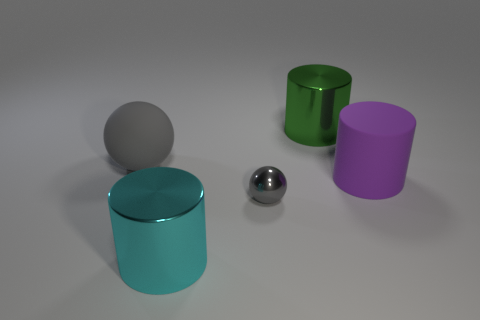What size is the object that is the same color as the small ball?
Your answer should be compact. Large. Is the large gray object the same shape as the purple thing?
Your response must be concise. No. What size is the other metal object that is the same shape as the large cyan shiny thing?
Keep it short and to the point. Large. The rubber thing to the left of the large cylinder that is behind the big gray rubber ball is what shape?
Ensure brevity in your answer.  Sphere. The purple rubber thing has what size?
Ensure brevity in your answer.  Large. What is the shape of the purple object?
Your response must be concise. Cylinder. There is a large gray object; is its shape the same as the gray object that is in front of the large gray ball?
Give a very brief answer. Yes. There is a big matte thing on the right side of the small gray sphere; is its shape the same as the cyan metallic thing?
Your response must be concise. Yes. How many large objects are both behind the gray metallic ball and right of the large gray matte thing?
Offer a terse response. 2. How many other things are the same size as the rubber cylinder?
Your response must be concise. 3. 